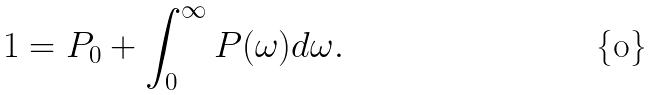Convert formula to latex. <formula><loc_0><loc_0><loc_500><loc_500>1 = P _ { 0 } + \int _ { 0 } ^ { \infty } P ( \omega ) d \omega .</formula> 